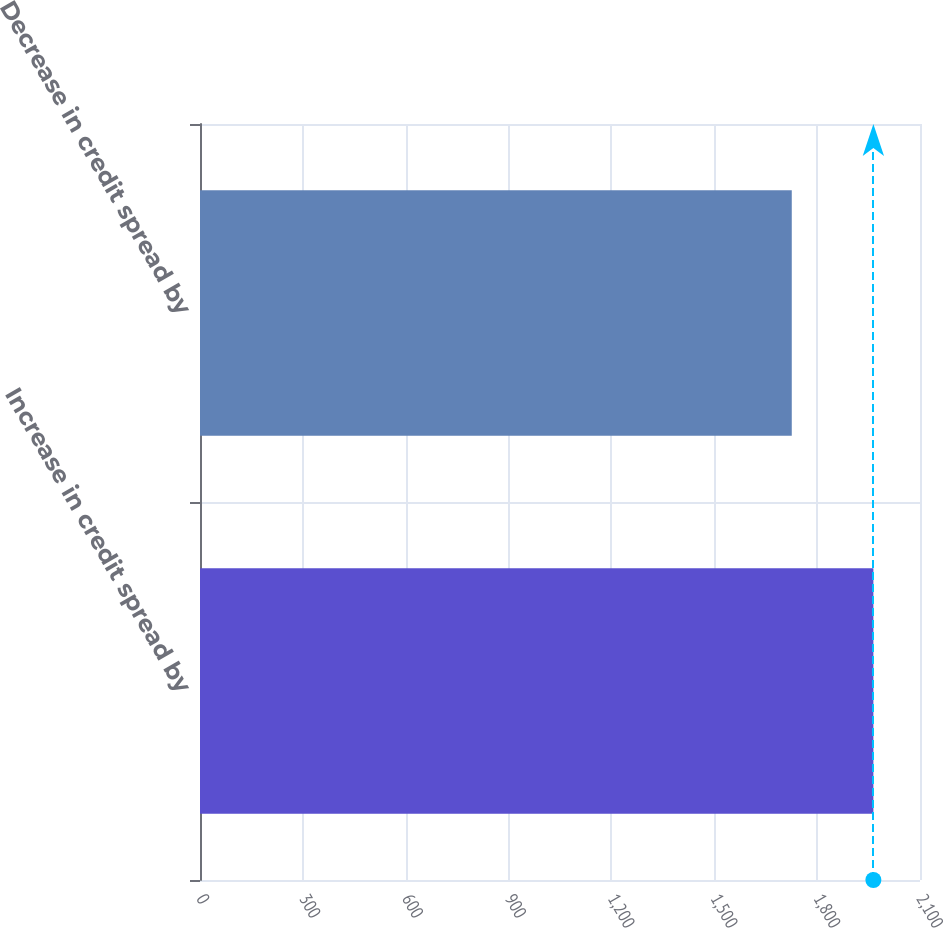Convert chart to OTSL. <chart><loc_0><loc_0><loc_500><loc_500><bar_chart><fcel>Increase in credit spread by<fcel>Decrease in credit spread by<nl><fcel>1964<fcel>1726<nl></chart> 